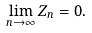Convert formula to latex. <formula><loc_0><loc_0><loc_500><loc_500>\lim _ { n \rightarrow \infty } Z _ { n } = 0 .</formula> 